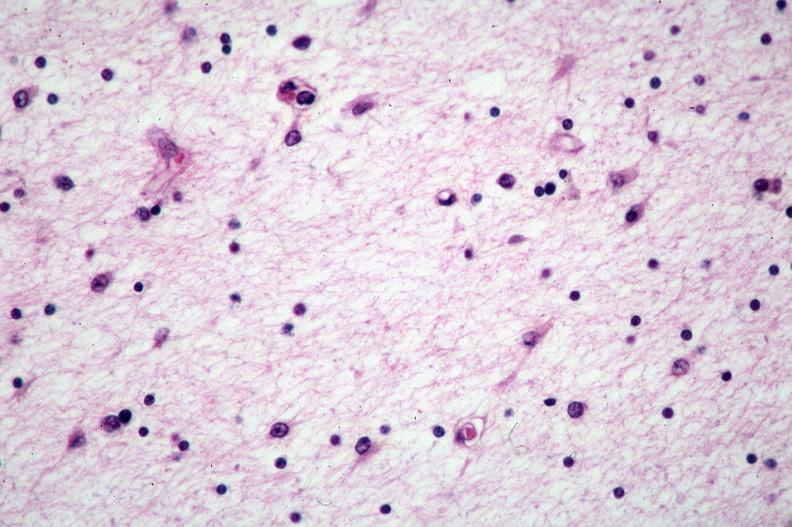does high excellent steroid show brain, pick 's disease?
Answer the question using a single word or phrase. No 